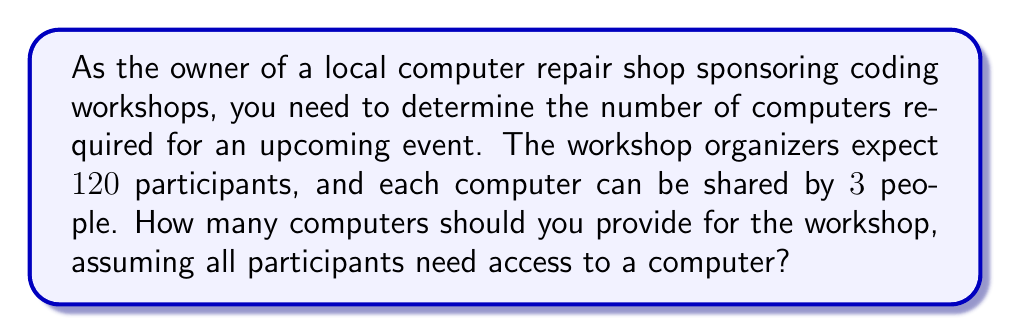Could you help me with this problem? To solve this problem, we need to divide the total number of participants by the number of people who can share each computer. This will give us the number of computers required.

Let's break it down step by step:

1. Number of participants: $120$
2. Number of people who can share each computer: $3$

We can express this as a division problem:

$$\text{Number of computers} = \frac{\text{Number of participants}}{\text{People per computer}}$$

Plugging in the values:

$$\text{Number of computers} = \frac{120}{3}$$

Now, let's perform the division:

$$\text{Number of computers} = 40$$

Therefore, you should provide $40$ computers for the workshop to ensure all participants have access to a computer.
Answer: $40$ computers 